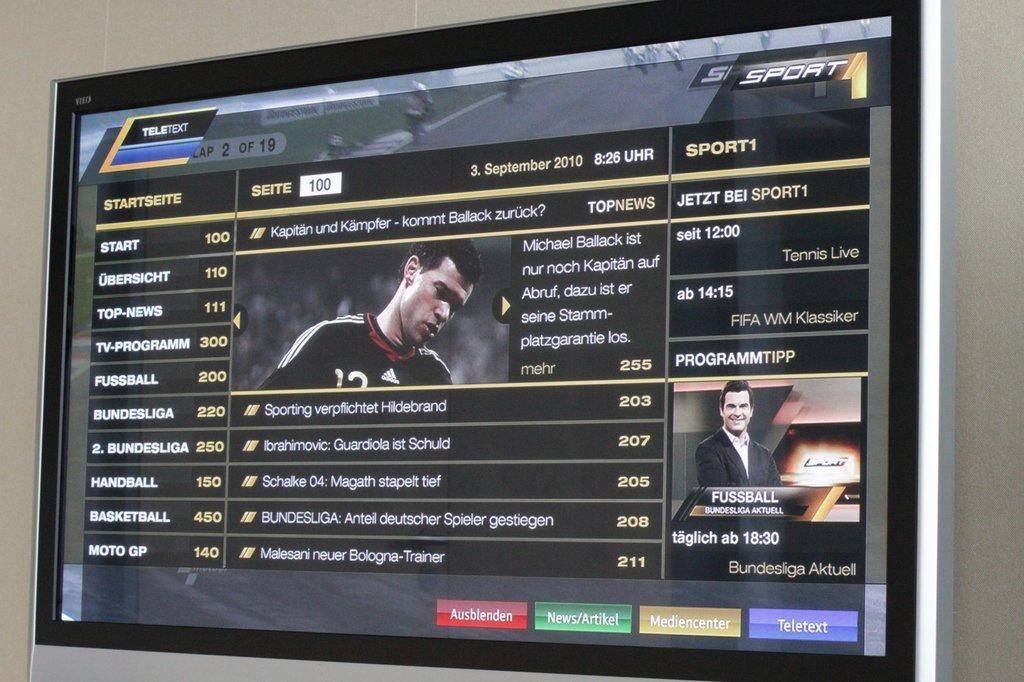Describe this image in one or two sentences. Television with screen. On this screen there are two people. 